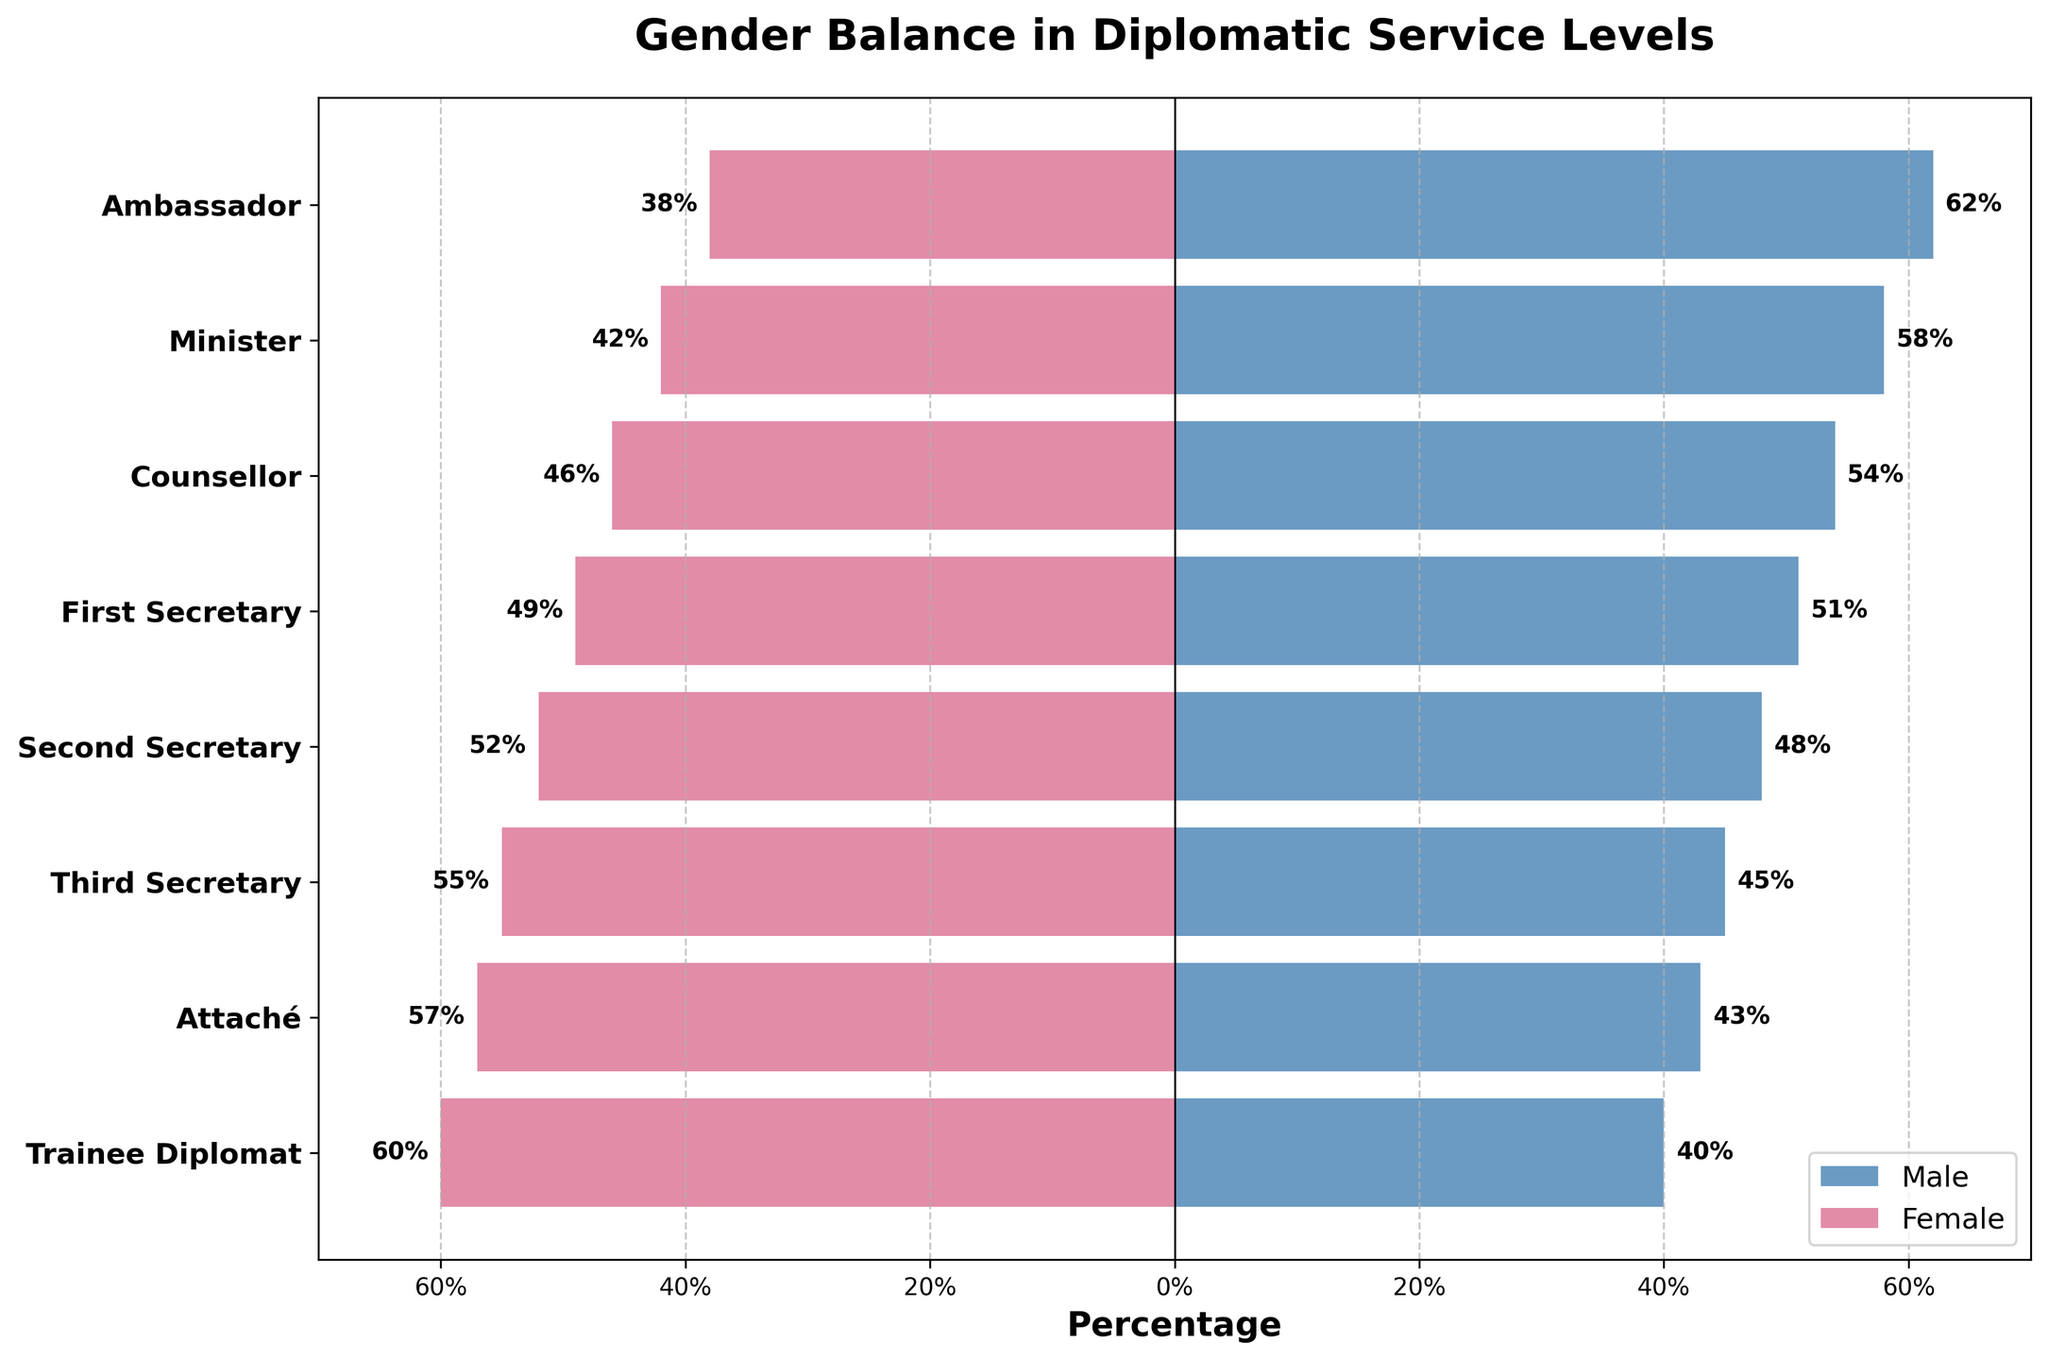What's the title of the figure? The title of the figure is found at the top center of the chart, depicting the main theme or subject of the figure.
Answer: Gender Balance in Diplomatic Service Levels How many levels of diplomatic service are shown in the figure? Count the number of distinct labels along the y-axis, each representing a level of diplomatic service.
Answer: 8 Which gender has a higher percentage at the Ambassador level? Compare the bar lengths for both males and females at the Ambassador level; the longer bar indicates the higher percentage.
Answer: Male What is the percentage difference between males and females at the Third Secretary level? Subtract the percentage of males from the percentage of females at the Third Secretary level. 55% - 45% = 10%
Answer: 10% At which level do males and females have nearly equal representation? Find the level where the bars for males and females are closest in length, showing near-equal percentages.
Answer: First Secretary Which gender has the highest percentage among Trainee Diplomats? Observe the longer bar at the Trainee Diplomat level, indicating the gender with the higher percentage.
Answer: Female What is the combined percentage of males and females at the Attaché level? Add the percentage of males and females at the Attaché level. 43% (male) + 57% (female) = 100%
Answer: 100% At which level is the female representation the highest? Identify the bar with the longest negative length (to the left) representing the highest female percentage.
Answer: Trainee Diplomat Compare the percentage of males at the Minister and Second Secretary levels. Which level has a higher percentage? Look at the length of the male bars at both the Minister and Second Secretary levels and determine which is longer.
Answer: Minister How does the gender balance shift from Ambassador to Attaché levels? Observing the trend from Ambassador to Attaché levels, there is a decline in the percentage of males and an increase in the percentage of females. Ambassadors start at 62% male, 38% female, shifting towards 43% male, 57% female as Attachés.
Answer: Decline in males, increase in females 